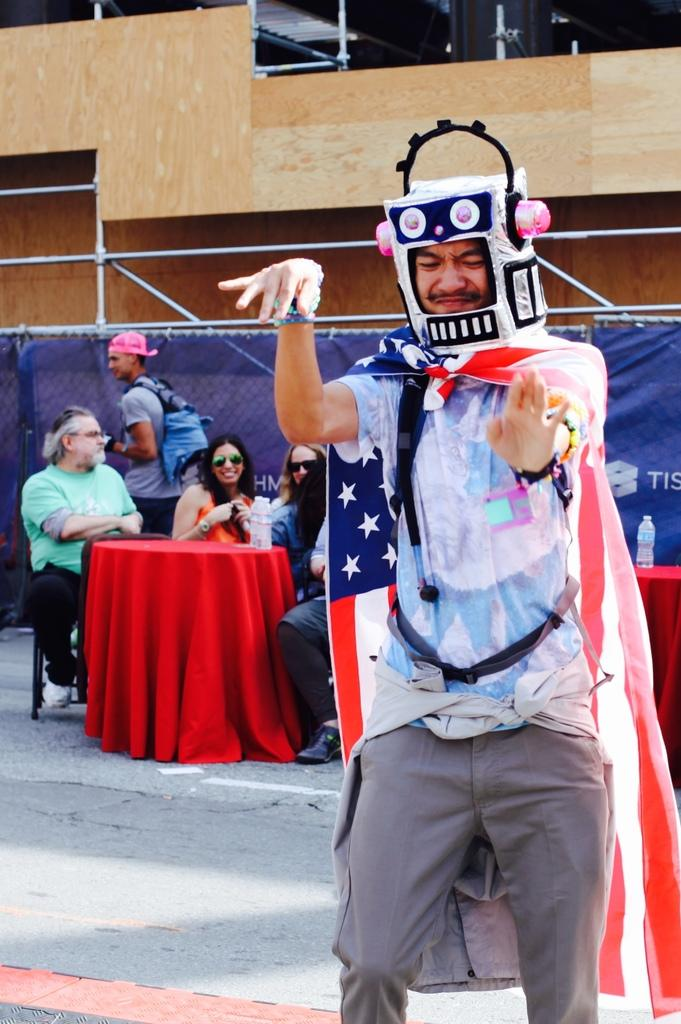How many people are in the image? There is a group of people in the image, but the exact number is not specified. What are some people doing in the image? Some people are sitting on chairs in the image. What can be seen on the tables in front of the people? There are bottles on the tables in front of the people. What type of structure can be seen behind the people? There are metal rods visible behind the people. What type of owl can be seen perched on the metal rods in the image? There is no owl present in the image; only people, chairs, bottles, and metal rods are visible. 